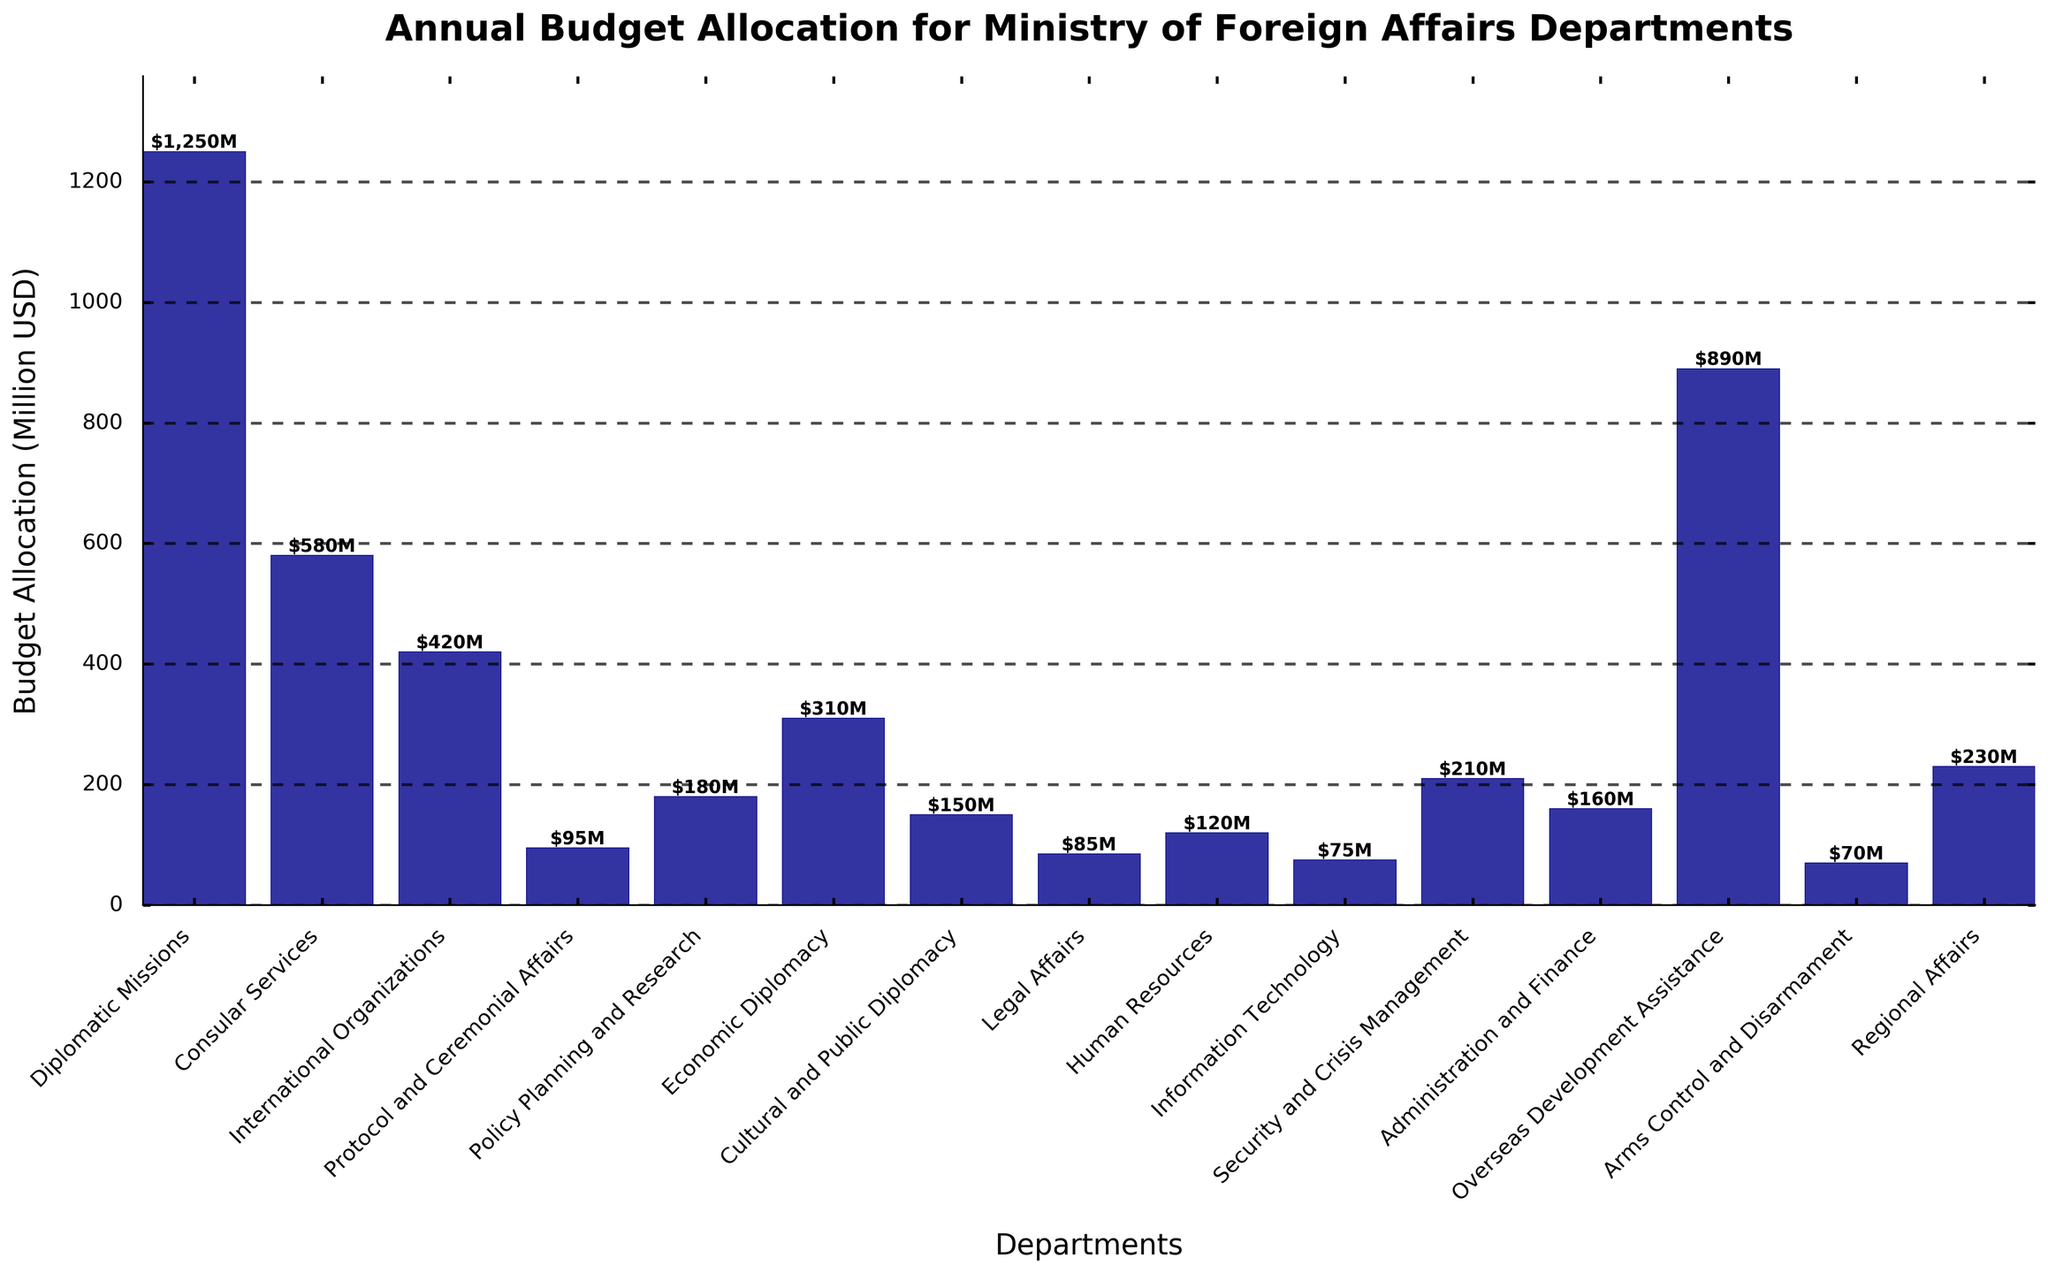Which department has the highest budget allocation? The tallest bar in the chart shows the department with the highest budget allocation. The department "Diplomatic Missions" has the tallest bar, indicating it has the highest budget allocation.
Answer: Diplomatic Missions Which departments have a budget allocation higher than $500 million? Look for bars in the chart whose height represent budget allocations greater than $500 million. "Diplomatic Missions" and "Overseas Development Assistance" have budget allocations of $1250 million and $890 million, respectively, which are both higher than $500 million.
Answer: Diplomatic Missions, Overseas Development Assistance What is the total budget allocation for Consular Services and Legal Affairs? Find the heights of the bars corresponding to "Consular Services" and "Legal Affairs." The budget allocation for "Consular Services" is $580 million, and for "Legal Affairs" it is $85 million. Adding these values gives 580 + 85 = 665.
Answer: 665 million USD Which department has the lowest budget allocation? The shortest bar in the chart indicates the department with the lowest budget allocation. The department "Arms Control and Disarmament" has the shortest bar, indicating it has the lowest budget allocation.
Answer: Arms Control and Disarmament How much more is allocated to Economic Diplomacy than Protocol and Ceremonial Affairs? Find the heights of the bars representing "Economic Diplomacy" ($310 million) and "Protocol and Ceremonial Affairs" ($95 million). Subtract the budget of "Protocol and Ceremonial Affairs" from that of "Economic Diplomacy": 310 - 95 = 215.
Answer: 215 million USD What is the average budget allocation of Policy Planning and Research, Human Resources, and Security and Crisis Management? Find the heights of the bars corresponding to these departments: "Policy Planning and Research" ($180 million), "Human Resources" ($120 million), and "Security and Crisis Management" ($210 million). Sum these values and divide by the number of departments: (180 + 120 + 210)/3 = 510/3 = 170.
Answer: 170 million USD If the budget allocation for Overseas Development Assistance is increased by 10%, what will be the new allocation? Increase the budget of "Overseas Development Assistance" by 10%. Its current budget is $890 million. Calculate 10% of 890, which is 89, and add this to the original budget: 890 + 89 = 979.
Answer: 979 million USD Which departments have budget allocations falling between $100 million and $200 million? Look for bars whose heights indicate budget allocations between $100 million and $200 million. The departments "Policy Planning and Research" ($180 million), "Cultural and Public Diplomacy" ($150 million), "Human Resources" ($120 million), and "Administration and Finance" ($160 million) fall within this range.
Answer: Policy Planning and Research, Cultural and Public Diplomacy, Human Resources, Administration and Finance 